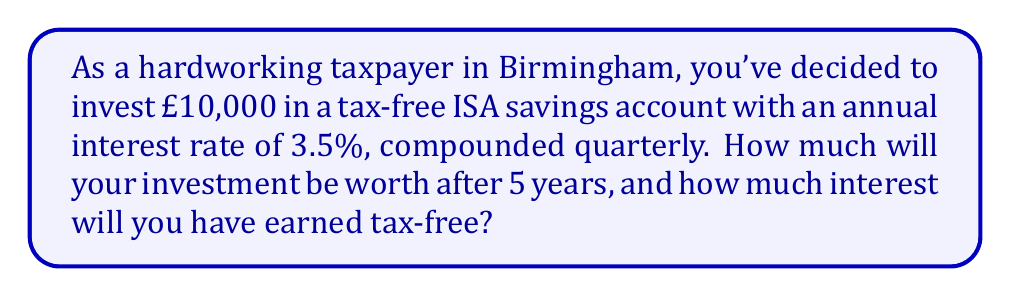Help me with this question. To solve this problem, we'll use the compound interest formula:

$$A = P(1 + \frac{r}{n})^{nt}$$

Where:
$A$ = Final amount
$P$ = Principal (initial investment)
$r$ = Annual interest rate (as a decimal)
$n$ = Number of times interest is compounded per year
$t$ = Number of years

Given:
$P = £10,000$
$r = 3.5\% = 0.035$
$n = 4$ (compounded quarterly)
$t = 5$ years

Let's calculate the final amount:

$$A = 10000(1 + \frac{0.035}{4})^{4 \times 5}$$
$$A = 10000(1.00875)^{20}$$
$$A = 10000 \times 1.190789$$
$$A = £11,907.89$$

To find the interest earned, we subtract the initial investment from the final amount:

Interest earned = Final amount - Initial investment
$$Interest = £11,907.89 - £10,000 = £1,907.89$$

This interest is earned tax-free in the ISA account.
Answer: After 5 years, the investment will be worth £11,907.89, and you will have earned £1,907.89 in tax-free interest. 